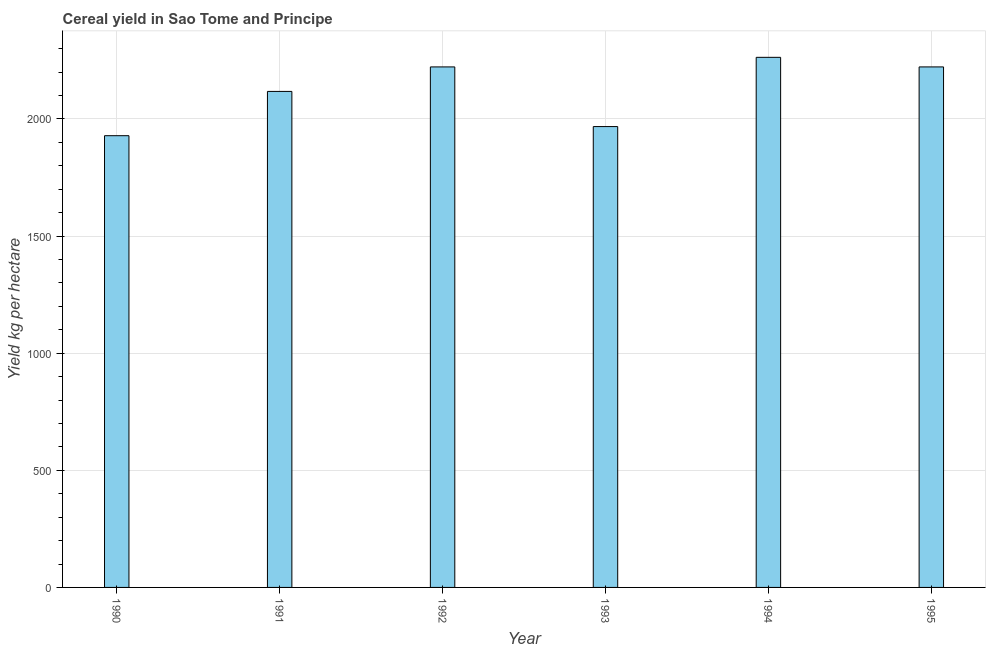Does the graph contain any zero values?
Your answer should be compact. No. Does the graph contain grids?
Give a very brief answer. Yes. What is the title of the graph?
Keep it short and to the point. Cereal yield in Sao Tome and Principe. What is the label or title of the Y-axis?
Your answer should be very brief. Yield kg per hectare. What is the cereal yield in 1995?
Your response must be concise. 2222.22. Across all years, what is the maximum cereal yield?
Provide a short and direct response. 2263.16. Across all years, what is the minimum cereal yield?
Give a very brief answer. 1928.57. In which year was the cereal yield minimum?
Your answer should be compact. 1990. What is the sum of the cereal yield?
Ensure brevity in your answer.  1.27e+04. What is the average cereal yield per year?
Your answer should be very brief. 2120.23. What is the median cereal yield?
Offer a very short reply. 2169.93. In how many years, is the cereal yield greater than 900 kg per hectare?
Your response must be concise. 6. What is the ratio of the cereal yield in 1992 to that in 1994?
Give a very brief answer. 0.98. Is the cereal yield in 1991 less than that in 1995?
Offer a terse response. Yes. Is the difference between the cereal yield in 1990 and 1992 greater than the difference between any two years?
Your response must be concise. No. What is the difference between the highest and the second highest cereal yield?
Ensure brevity in your answer.  40.94. Is the sum of the cereal yield in 1991 and 1994 greater than the maximum cereal yield across all years?
Offer a terse response. Yes. What is the difference between the highest and the lowest cereal yield?
Provide a succinct answer. 334.59. How many years are there in the graph?
Your response must be concise. 6. Are the values on the major ticks of Y-axis written in scientific E-notation?
Your answer should be very brief. No. What is the Yield kg per hectare of 1990?
Provide a short and direct response. 1928.57. What is the Yield kg per hectare of 1991?
Keep it short and to the point. 2117.65. What is the Yield kg per hectare of 1992?
Provide a short and direct response. 2222.22. What is the Yield kg per hectare of 1993?
Provide a succinct answer. 1967.54. What is the Yield kg per hectare of 1994?
Ensure brevity in your answer.  2263.16. What is the Yield kg per hectare of 1995?
Make the answer very short. 2222.22. What is the difference between the Yield kg per hectare in 1990 and 1991?
Provide a short and direct response. -189.08. What is the difference between the Yield kg per hectare in 1990 and 1992?
Offer a very short reply. -293.65. What is the difference between the Yield kg per hectare in 1990 and 1993?
Your response must be concise. -38.97. What is the difference between the Yield kg per hectare in 1990 and 1994?
Provide a short and direct response. -334.59. What is the difference between the Yield kg per hectare in 1990 and 1995?
Your answer should be very brief. -293.65. What is the difference between the Yield kg per hectare in 1991 and 1992?
Make the answer very short. -104.58. What is the difference between the Yield kg per hectare in 1991 and 1993?
Offer a terse response. 150.11. What is the difference between the Yield kg per hectare in 1991 and 1994?
Offer a terse response. -145.51. What is the difference between the Yield kg per hectare in 1991 and 1995?
Ensure brevity in your answer.  -104.58. What is the difference between the Yield kg per hectare in 1992 and 1993?
Ensure brevity in your answer.  254.69. What is the difference between the Yield kg per hectare in 1992 and 1994?
Your response must be concise. -40.94. What is the difference between the Yield kg per hectare in 1992 and 1995?
Give a very brief answer. 0. What is the difference between the Yield kg per hectare in 1993 and 1994?
Ensure brevity in your answer.  -295.62. What is the difference between the Yield kg per hectare in 1993 and 1995?
Make the answer very short. -254.69. What is the difference between the Yield kg per hectare in 1994 and 1995?
Offer a very short reply. 40.94. What is the ratio of the Yield kg per hectare in 1990 to that in 1991?
Keep it short and to the point. 0.91. What is the ratio of the Yield kg per hectare in 1990 to that in 1992?
Offer a very short reply. 0.87. What is the ratio of the Yield kg per hectare in 1990 to that in 1993?
Your answer should be very brief. 0.98. What is the ratio of the Yield kg per hectare in 1990 to that in 1994?
Keep it short and to the point. 0.85. What is the ratio of the Yield kg per hectare in 1990 to that in 1995?
Keep it short and to the point. 0.87. What is the ratio of the Yield kg per hectare in 1991 to that in 1992?
Give a very brief answer. 0.95. What is the ratio of the Yield kg per hectare in 1991 to that in 1993?
Make the answer very short. 1.08. What is the ratio of the Yield kg per hectare in 1991 to that in 1994?
Ensure brevity in your answer.  0.94. What is the ratio of the Yield kg per hectare in 1991 to that in 1995?
Provide a short and direct response. 0.95. What is the ratio of the Yield kg per hectare in 1992 to that in 1993?
Your answer should be compact. 1.13. What is the ratio of the Yield kg per hectare in 1992 to that in 1995?
Keep it short and to the point. 1. What is the ratio of the Yield kg per hectare in 1993 to that in 1994?
Offer a terse response. 0.87. What is the ratio of the Yield kg per hectare in 1993 to that in 1995?
Give a very brief answer. 0.89. What is the ratio of the Yield kg per hectare in 1994 to that in 1995?
Provide a short and direct response. 1.02. 